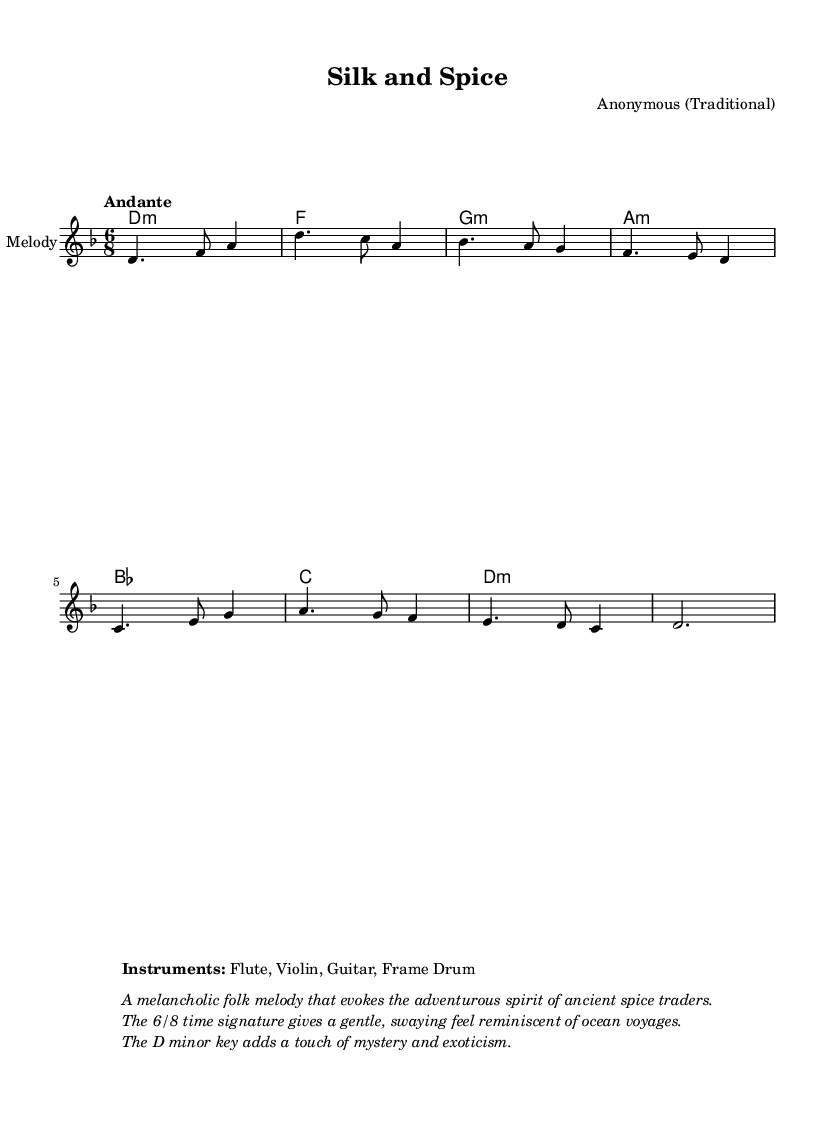What is the key signature of this music? The key signature is D minor, which has one flat (B flat). This is indicated at the beginning of the music staff.
Answer: D minor What is the time signature of this piece? The time signature is 6/8, which means there are six eighth notes per measure. This is shown at the beginning of the sheet music next to the key signature.
Answer: 6/8 What is the tempo marking of the music? The tempo marking is "Andante," which indicates a moderate walking speed. This is specified above the staff in the sheet music.
Answer: Andante How many measures are present in the melody? There are eight measures in the melody as indicated by the groupings of notes. Counting the distinct bar lines in the melody confirms this total.
Answer: Eight What instruments are indicated for this piece? The indicated instruments are Flute, Violin, Guitar, and Frame Drum, and this information is listed within the markup section at the bottom of the sheet music.
Answer: Flute, Violin, Guitar, Frame Drum What is the primary theme depicted in the lyrics of this piece? The primary theme revolves around the spice trade and its wonders, as reflected in the lyrics, which describe exotic treasures and the journey of merchants across seas. The tone of the lyrics indicates a storytelling aspect tied to the adventure.
Answer: Spice trade What emotional quality does the music evoke according to the markup? The music evokes a melancholic quality, which is described in the markup section as reflecting the adventurous spirit of ancient spice traders. This corresponds to the overall mood created by the D minor key and the rhythmic flow.
Answer: Melancholic 